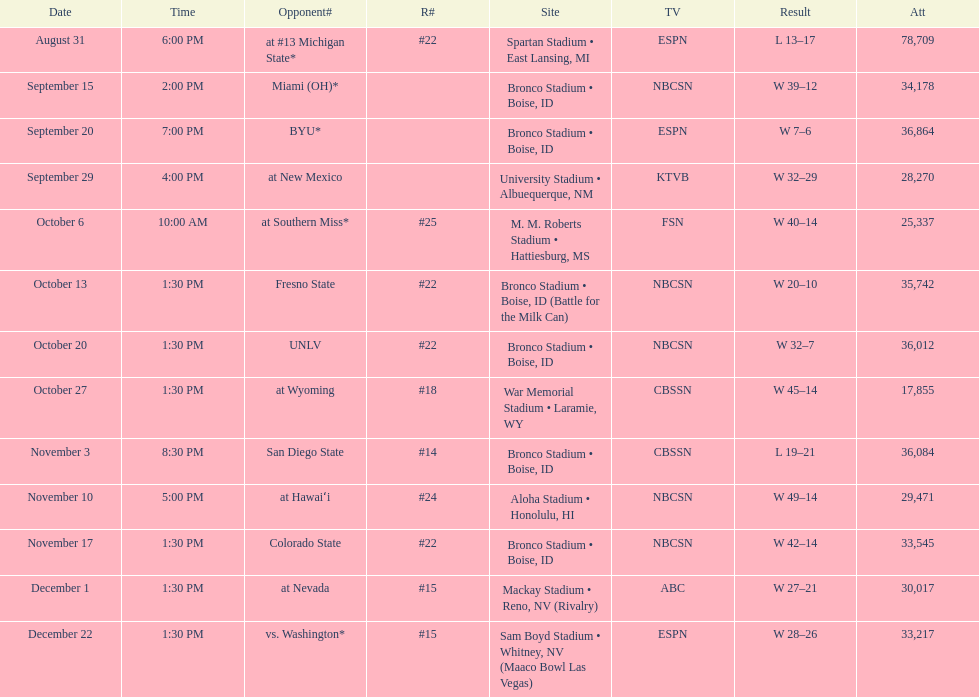Number of points scored by miami (oh) against the broncos. 12. 